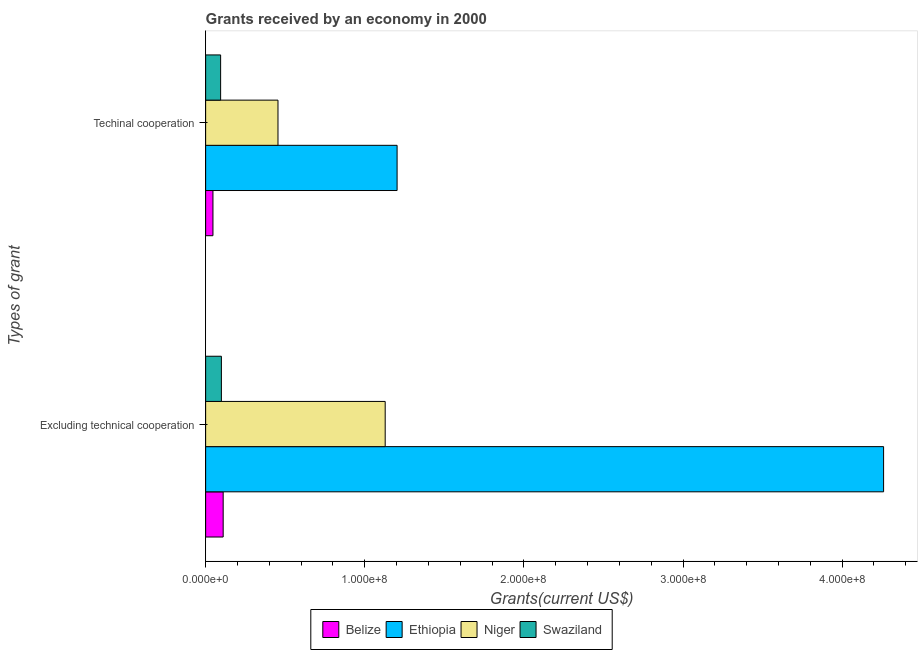How many different coloured bars are there?
Offer a terse response. 4. Are the number of bars on each tick of the Y-axis equal?
Provide a succinct answer. Yes. How many bars are there on the 1st tick from the top?
Your answer should be very brief. 4. How many bars are there on the 2nd tick from the bottom?
Offer a very short reply. 4. What is the label of the 2nd group of bars from the top?
Make the answer very short. Excluding technical cooperation. What is the amount of grants received(including technical cooperation) in Ethiopia?
Your response must be concise. 1.20e+08. Across all countries, what is the maximum amount of grants received(including technical cooperation)?
Offer a very short reply. 1.20e+08. Across all countries, what is the minimum amount of grants received(including technical cooperation)?
Make the answer very short. 4.60e+06. In which country was the amount of grants received(excluding technical cooperation) maximum?
Keep it short and to the point. Ethiopia. In which country was the amount of grants received(including technical cooperation) minimum?
Ensure brevity in your answer.  Belize. What is the total amount of grants received(excluding technical cooperation) in the graph?
Your response must be concise. 5.60e+08. What is the difference between the amount of grants received(excluding technical cooperation) in Belize and that in Niger?
Make the answer very short. -1.02e+08. What is the difference between the amount of grants received(including technical cooperation) in Ethiopia and the amount of grants received(excluding technical cooperation) in Niger?
Your answer should be compact. 7.48e+06. What is the average amount of grants received(including technical cooperation) per country?
Give a very brief answer. 4.50e+07. What is the difference between the amount of grants received(excluding technical cooperation) and amount of grants received(including technical cooperation) in Niger?
Your answer should be compact. 6.74e+07. In how many countries, is the amount of grants received(excluding technical cooperation) greater than 340000000 US$?
Your answer should be very brief. 1. What is the ratio of the amount of grants received(including technical cooperation) in Swaziland to that in Niger?
Provide a succinct answer. 0.21. Is the amount of grants received(including technical cooperation) in Belize less than that in Ethiopia?
Ensure brevity in your answer.  Yes. In how many countries, is the amount of grants received(excluding technical cooperation) greater than the average amount of grants received(excluding technical cooperation) taken over all countries?
Keep it short and to the point. 1. What does the 1st bar from the top in Excluding technical cooperation represents?
Provide a short and direct response. Swaziland. What does the 1st bar from the bottom in Techinal cooperation represents?
Offer a very short reply. Belize. Are all the bars in the graph horizontal?
Ensure brevity in your answer.  Yes. Does the graph contain any zero values?
Provide a succinct answer. No. How are the legend labels stacked?
Your answer should be very brief. Horizontal. What is the title of the graph?
Offer a very short reply. Grants received by an economy in 2000. What is the label or title of the X-axis?
Keep it short and to the point. Grants(current US$). What is the label or title of the Y-axis?
Your response must be concise. Types of grant. What is the Grants(current US$) in Belize in Excluding technical cooperation?
Offer a very short reply. 1.10e+07. What is the Grants(current US$) in Ethiopia in Excluding technical cooperation?
Ensure brevity in your answer.  4.26e+08. What is the Grants(current US$) of Niger in Excluding technical cooperation?
Offer a terse response. 1.13e+08. What is the Grants(current US$) in Swaziland in Excluding technical cooperation?
Give a very brief answer. 9.90e+06. What is the Grants(current US$) in Belize in Techinal cooperation?
Your answer should be compact. 4.60e+06. What is the Grants(current US$) in Ethiopia in Techinal cooperation?
Ensure brevity in your answer.  1.20e+08. What is the Grants(current US$) of Niger in Techinal cooperation?
Provide a succinct answer. 4.55e+07. What is the Grants(current US$) in Swaziland in Techinal cooperation?
Offer a very short reply. 9.42e+06. Across all Types of grant, what is the maximum Grants(current US$) in Belize?
Offer a very short reply. 1.10e+07. Across all Types of grant, what is the maximum Grants(current US$) in Ethiopia?
Your response must be concise. 4.26e+08. Across all Types of grant, what is the maximum Grants(current US$) in Niger?
Make the answer very short. 1.13e+08. Across all Types of grant, what is the maximum Grants(current US$) in Swaziland?
Your answer should be very brief. 9.90e+06. Across all Types of grant, what is the minimum Grants(current US$) of Belize?
Offer a very short reply. 4.60e+06. Across all Types of grant, what is the minimum Grants(current US$) in Ethiopia?
Offer a terse response. 1.20e+08. Across all Types of grant, what is the minimum Grants(current US$) in Niger?
Your response must be concise. 4.55e+07. Across all Types of grant, what is the minimum Grants(current US$) in Swaziland?
Your response must be concise. 9.42e+06. What is the total Grants(current US$) of Belize in the graph?
Ensure brevity in your answer.  1.56e+07. What is the total Grants(current US$) in Ethiopia in the graph?
Keep it short and to the point. 5.46e+08. What is the total Grants(current US$) in Niger in the graph?
Offer a terse response. 1.58e+08. What is the total Grants(current US$) in Swaziland in the graph?
Your answer should be very brief. 1.93e+07. What is the difference between the Grants(current US$) in Belize in Excluding technical cooperation and that in Techinal cooperation?
Offer a very short reply. 6.42e+06. What is the difference between the Grants(current US$) in Ethiopia in Excluding technical cooperation and that in Techinal cooperation?
Your answer should be very brief. 3.06e+08. What is the difference between the Grants(current US$) in Niger in Excluding technical cooperation and that in Techinal cooperation?
Your answer should be compact. 6.74e+07. What is the difference between the Grants(current US$) of Belize in Excluding technical cooperation and the Grants(current US$) of Ethiopia in Techinal cooperation?
Offer a terse response. -1.09e+08. What is the difference between the Grants(current US$) in Belize in Excluding technical cooperation and the Grants(current US$) in Niger in Techinal cooperation?
Give a very brief answer. -3.44e+07. What is the difference between the Grants(current US$) of Belize in Excluding technical cooperation and the Grants(current US$) of Swaziland in Techinal cooperation?
Provide a succinct answer. 1.60e+06. What is the difference between the Grants(current US$) in Ethiopia in Excluding technical cooperation and the Grants(current US$) in Niger in Techinal cooperation?
Provide a succinct answer. 3.81e+08. What is the difference between the Grants(current US$) of Ethiopia in Excluding technical cooperation and the Grants(current US$) of Swaziland in Techinal cooperation?
Offer a very short reply. 4.17e+08. What is the difference between the Grants(current US$) in Niger in Excluding technical cooperation and the Grants(current US$) in Swaziland in Techinal cooperation?
Give a very brief answer. 1.03e+08. What is the average Grants(current US$) of Belize per Types of grant?
Offer a very short reply. 7.81e+06. What is the average Grants(current US$) of Ethiopia per Types of grant?
Give a very brief answer. 2.73e+08. What is the average Grants(current US$) of Niger per Types of grant?
Your answer should be compact. 7.92e+07. What is the average Grants(current US$) in Swaziland per Types of grant?
Make the answer very short. 9.66e+06. What is the difference between the Grants(current US$) of Belize and Grants(current US$) of Ethiopia in Excluding technical cooperation?
Make the answer very short. -4.15e+08. What is the difference between the Grants(current US$) in Belize and Grants(current US$) in Niger in Excluding technical cooperation?
Provide a short and direct response. -1.02e+08. What is the difference between the Grants(current US$) in Belize and Grants(current US$) in Swaziland in Excluding technical cooperation?
Give a very brief answer. 1.12e+06. What is the difference between the Grants(current US$) of Ethiopia and Grants(current US$) of Niger in Excluding technical cooperation?
Your answer should be very brief. 3.13e+08. What is the difference between the Grants(current US$) of Ethiopia and Grants(current US$) of Swaziland in Excluding technical cooperation?
Give a very brief answer. 4.16e+08. What is the difference between the Grants(current US$) of Niger and Grants(current US$) of Swaziland in Excluding technical cooperation?
Offer a very short reply. 1.03e+08. What is the difference between the Grants(current US$) in Belize and Grants(current US$) in Ethiopia in Techinal cooperation?
Keep it short and to the point. -1.16e+08. What is the difference between the Grants(current US$) of Belize and Grants(current US$) of Niger in Techinal cooperation?
Provide a succinct answer. -4.09e+07. What is the difference between the Grants(current US$) of Belize and Grants(current US$) of Swaziland in Techinal cooperation?
Give a very brief answer. -4.82e+06. What is the difference between the Grants(current US$) of Ethiopia and Grants(current US$) of Niger in Techinal cooperation?
Your response must be concise. 7.48e+07. What is the difference between the Grants(current US$) of Ethiopia and Grants(current US$) of Swaziland in Techinal cooperation?
Give a very brief answer. 1.11e+08. What is the difference between the Grants(current US$) in Niger and Grants(current US$) in Swaziland in Techinal cooperation?
Keep it short and to the point. 3.60e+07. What is the ratio of the Grants(current US$) of Belize in Excluding technical cooperation to that in Techinal cooperation?
Ensure brevity in your answer.  2.4. What is the ratio of the Grants(current US$) of Ethiopia in Excluding technical cooperation to that in Techinal cooperation?
Offer a terse response. 3.54. What is the ratio of the Grants(current US$) in Niger in Excluding technical cooperation to that in Techinal cooperation?
Offer a terse response. 2.48. What is the ratio of the Grants(current US$) of Swaziland in Excluding technical cooperation to that in Techinal cooperation?
Provide a succinct answer. 1.05. What is the difference between the highest and the second highest Grants(current US$) in Belize?
Offer a terse response. 6.42e+06. What is the difference between the highest and the second highest Grants(current US$) in Ethiopia?
Your response must be concise. 3.06e+08. What is the difference between the highest and the second highest Grants(current US$) of Niger?
Ensure brevity in your answer.  6.74e+07. What is the difference between the highest and the lowest Grants(current US$) in Belize?
Your answer should be very brief. 6.42e+06. What is the difference between the highest and the lowest Grants(current US$) in Ethiopia?
Ensure brevity in your answer.  3.06e+08. What is the difference between the highest and the lowest Grants(current US$) of Niger?
Provide a short and direct response. 6.74e+07. What is the difference between the highest and the lowest Grants(current US$) in Swaziland?
Offer a terse response. 4.80e+05. 